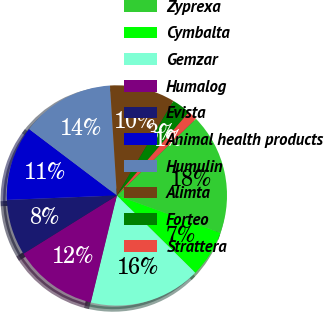Convert chart to OTSL. <chart><loc_0><loc_0><loc_500><loc_500><pie_chart><fcel>Zyprexa<fcel>Cymbalta<fcel>Gemzar<fcel>Humalog<fcel>Evista<fcel>Animal health products<fcel>Humulin<fcel>Alimta<fcel>Forteo<fcel>Strattera<nl><fcel>17.79%<fcel>6.86%<fcel>16.42%<fcel>12.32%<fcel>8.22%<fcel>10.96%<fcel>13.69%<fcel>9.59%<fcel>2.76%<fcel>1.39%<nl></chart> 